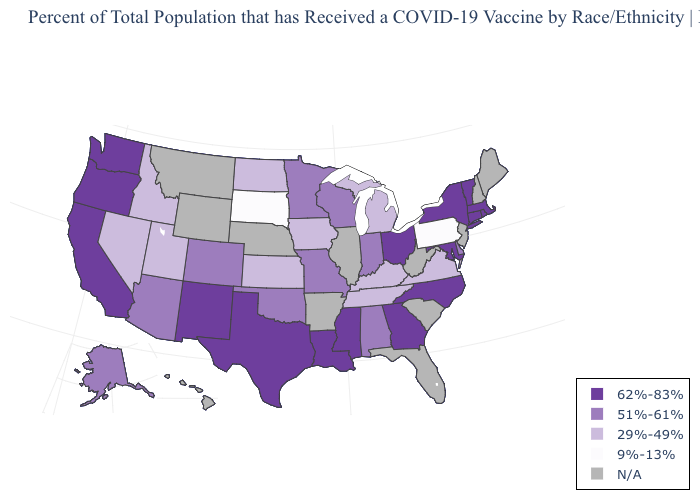What is the value of New Hampshire?
Keep it brief. N/A. Name the states that have a value in the range N/A?
Write a very short answer. Arkansas, Florida, Hawaii, Illinois, Maine, Montana, Nebraska, New Hampshire, New Jersey, South Carolina, West Virginia, Wyoming. What is the highest value in the USA?
Short answer required. 62%-83%. Name the states that have a value in the range 51%-61%?
Concise answer only. Alabama, Alaska, Arizona, Colorado, Delaware, Indiana, Minnesota, Missouri, Oklahoma, Wisconsin. What is the lowest value in states that border Tennessee?
Write a very short answer. 29%-49%. Name the states that have a value in the range N/A?
Give a very brief answer. Arkansas, Florida, Hawaii, Illinois, Maine, Montana, Nebraska, New Hampshire, New Jersey, South Carolina, West Virginia, Wyoming. Does the first symbol in the legend represent the smallest category?
Keep it brief. No. Does South Dakota have the lowest value in the USA?
Answer briefly. Yes. Which states have the lowest value in the USA?
Short answer required. Pennsylvania, South Dakota. What is the highest value in the South ?
Answer briefly. 62%-83%. Does South Dakota have the lowest value in the MidWest?
Write a very short answer. Yes. Does Connecticut have the highest value in the USA?
Concise answer only. Yes. Is the legend a continuous bar?
Give a very brief answer. No. 